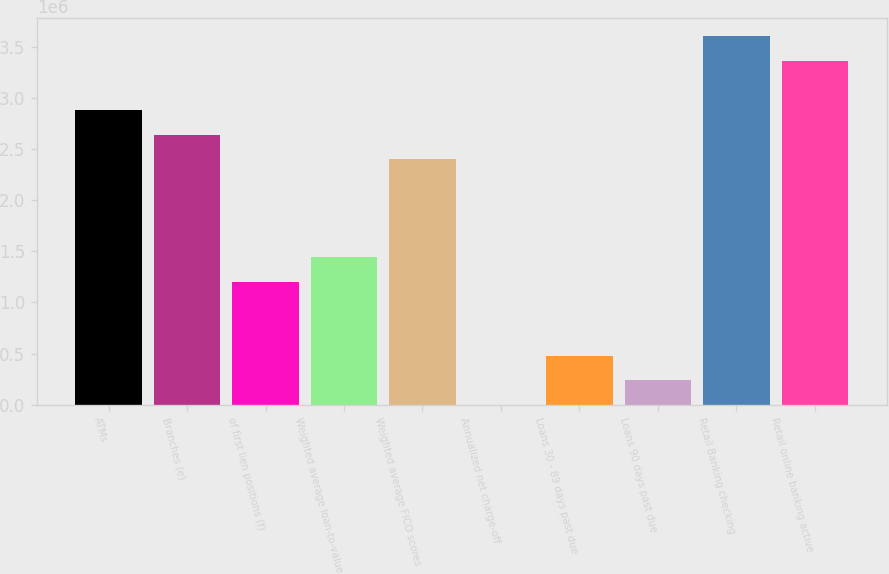Convert chart. <chart><loc_0><loc_0><loc_500><loc_500><bar_chart><fcel>ATMs<fcel>Branches (e)<fcel>of first lien positions (f)<fcel>Weighted average loan-to-value<fcel>Weighted average FICO scores<fcel>Annualized net charge-off<fcel>Loans 30 - 89 days past due<fcel>Loans 90 days past due<fcel>Retail Banking checking<fcel>Retail online banking active<nl><fcel>2.8824e+06<fcel>2.6422e+06<fcel>1.201e+06<fcel>1.4412e+06<fcel>2.402e+06<fcel>0.49<fcel>480400<fcel>240200<fcel>3.603e+06<fcel>3.3628e+06<nl></chart> 